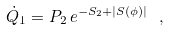Convert formula to latex. <formula><loc_0><loc_0><loc_500><loc_500>\dot { Q } _ { 1 } = P _ { 2 } \, e ^ { - { S _ { 2 } } + | S ( \phi ) | } \ ,</formula> 